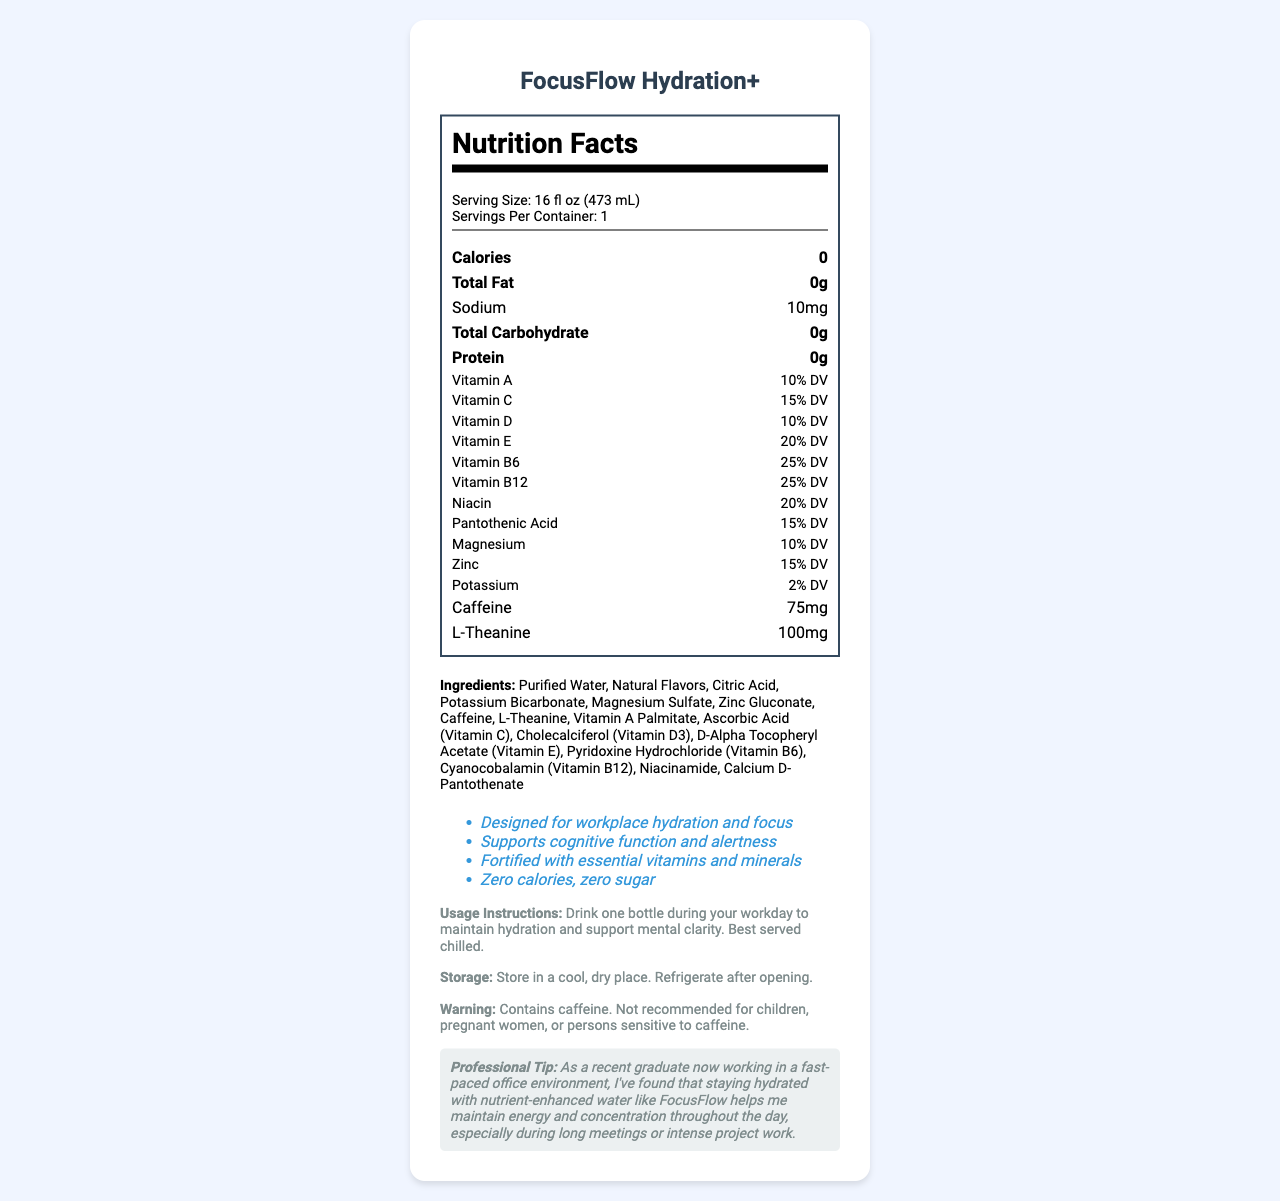what is the serving size of FocusFlow Hydration+? The serving size is listed in the serving information section of the document as "16 fl oz (473 mL)".
Answer: 16 fl oz (473 mL) how much caffeine is in one serving? The nutrient row for caffeine shows that one serving contains 75mg of caffeine.
Answer: 75mg list three main ingredients in FocusFlow Hydration+ The ingredients section lists all the ingredients, with the first three being Purified Water, Natural Flavors, and Citric Acid.
Answer: Purified Water, Natural Flavors, Citric Acid what percentage of the daily value for Vitamin B12 does one serving provide? The vitamin row for Vitamin B12 indicates a 25% daily value per serving.
Answer: 25% DV where should the product be stored after opening? The storage section specifies "Refrigerate after opening."
Answer: Refrigerate after opening which vitamin has the highest daily value percentage in FocusFlow Hydration+?
A. Vitamin A
B. Vitamin C
C. Vitamin E
D. Vitamin B6 The vitamin row shows that Vitamin E provides 20% DV, which is higher than Vitamin A (10%), Vitamin C (15%), and Vitamin B6 (25%).
Answer: C. Vitamin E how many servings are in each container of FocusFlow Hydration+?
I. 1 serving
II. 2 servings
III. 3 servings
IV. 4 servings The servings per container information is given as "1".
Answer: I. 1 serving does this product contain sugar? The marketing claims section states "Zero calories, zero sugar".
Answer: No is this product recommended for children? The caffeine warning specifies that it is not recommended for children due to the caffeine content.
Answer: No describe the main purpose of FocusFlow Hydration+ in one sentence. Reviewing the document, it highlights that the product is marketed for workplace hydration and cognitive function support.
Answer: FocusFlow Hydration+ is a vitamin-fortified bottled water designed to support workplace hydration and focus. how much L-Theanine is in the product? The nutrient row for L-Theanine shows 100mg per serving.
Answer: 100mg what vitamin is not listed in the Nutrition Facts of FocusFlow Hydration+? Vitamin K is not listed among the vitamins included in the Nutrition Facts.
Answer: Vitamin K what color is the background of the outer container? The visual layout of the document doesn't provide any information about the color of the product's outer container.
Answer: Cannot be determined what is the total fat content in FocusFlow Hydration+? The total fat is listed as "0g" in the nutrient row for Total Fat.
Answer: 0g give an example of a professional's suggestion for using FocusFlow Hydration+ The professional tip section mentions using the product to maintain energy and concentration during intensive work.
Answer: Drinking the product to maintain energy and concentration during long meetings or intense project work 